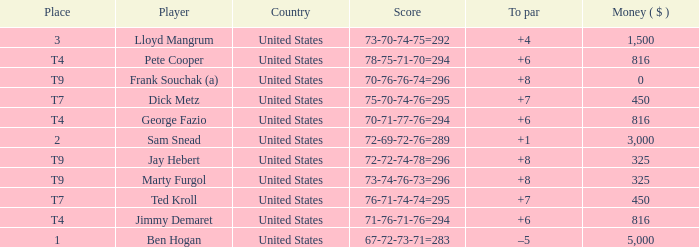How much was paid to the player whose score was 70-71-77-76=294? 816.0. 